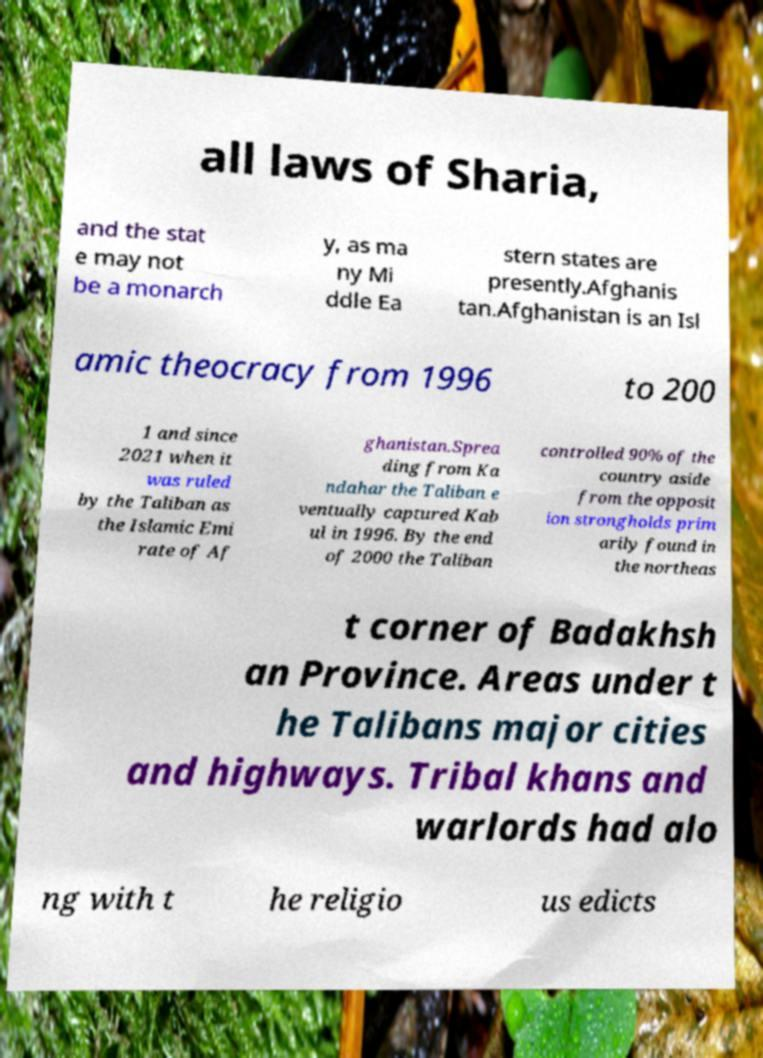Could you assist in decoding the text presented in this image and type it out clearly? all laws of Sharia, and the stat e may not be a monarch y, as ma ny Mi ddle Ea stern states are presently.Afghanis tan.Afghanistan is an Isl amic theocracy from 1996 to 200 1 and since 2021 when it was ruled by the Taliban as the Islamic Emi rate of Af ghanistan.Sprea ding from Ka ndahar the Taliban e ventually captured Kab ul in 1996. By the end of 2000 the Taliban controlled 90% of the country aside from the opposit ion strongholds prim arily found in the northeas t corner of Badakhsh an Province. Areas under t he Talibans major cities and highways. Tribal khans and warlords had alo ng with t he religio us edicts 